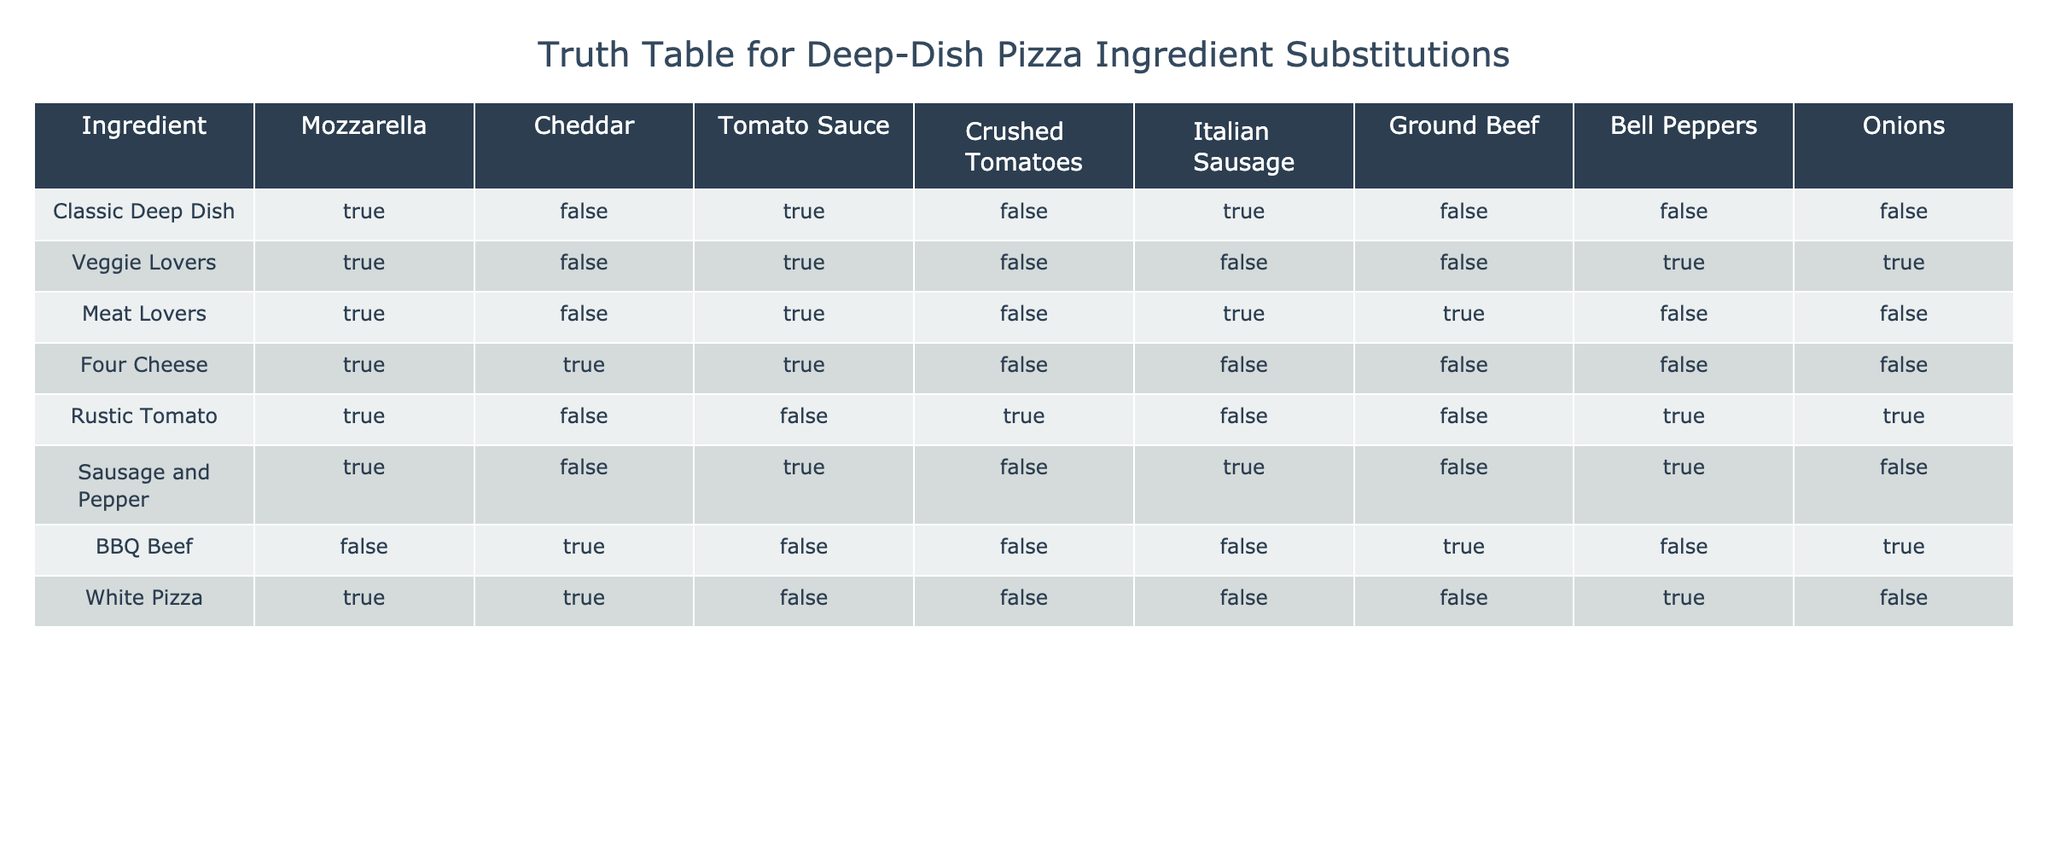What kind of cheese is used in the Meat Lovers deep-dish pizza? Meat Lovers deep-dish pizza has Mozzarella and Cheddar as its cheese ingredients, as indicated by the "TRUE" values in those columns for this row.
Answer: Mozzarella and Cheddar Is Tomato Sauce included in the White Pizza? The table shows that the White Pizza has "FALSE" in the Tomato Sauce column, indicating that it does not include this ingredient.
Answer: No How many pizzas listed use Ground Beef? The pizzas using Ground Beef are Meat Lovers and BBQ Beef, which are the only two rows with "TRUE" in the Ground Beef column. Thus, there are 2 pizzas that use this ingredient.
Answer: 2 Which deep-dish pizza includes both Onions and Bell Peppers? By examining the rows, the Sausage and Pepper pizza has "TRUE" for both Onions and Bell Peppers columns, making it the only one with both ingredients.
Answer: Sausage and Pepper Do any pizza recipes use both Cheddar and Crushed Tomatoes? The table indicates that Four Cheese and BBQ Beef are the only pizzas that include Cheddar, but they have "FALSE" for the Crushed Tomatoes column. Therefore, no pizzas use both ingredients.
Answer: No What is the total number of pizzas that have Mozzarella as an ingredient? All pizzas except BBQ Beef have "TRUE" for Mozzarella. This means there are 7 pizzas with Mozzarella (Classic Deep Dish, Veggie Lovers, Meat Lovers, Four Cheese, Rustic Tomato, Sausage and Pepper, and White Pizza).
Answer: 7 Is the Veggie Lovers pizza considered a meatless pizza? Since the Veggie Lovers pizza has "FALSE" values for Italian Sausage and Ground Beef while being "TRUE" for the vegetable ingredients (Bell Peppers and Onions), it confirms that it does not contain any meat.
Answer: Yes Which pizza has the maximum variety of cheese? The Four Cheese pizza has both Mozzarella and Cheddar marked as "TRUE," which indicates it contains the most variety of cheese compared to other pizza types in the table.
Answer: Four Cheese 